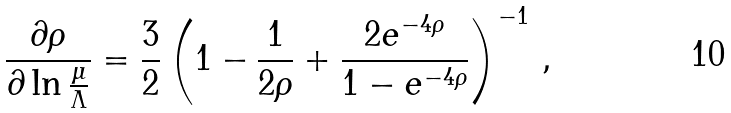Convert formula to latex. <formula><loc_0><loc_0><loc_500><loc_500>\frac { \partial \rho } { \partial \ln \frac { \mu } { \Lambda } } = \frac { 3 } { 2 } \left ( 1 - \frac { 1 } { 2 \rho } + \frac { 2 e ^ { - 4 \rho } } { 1 - e ^ { - 4 \rho } } \right ) ^ { - 1 } \, ,</formula> 